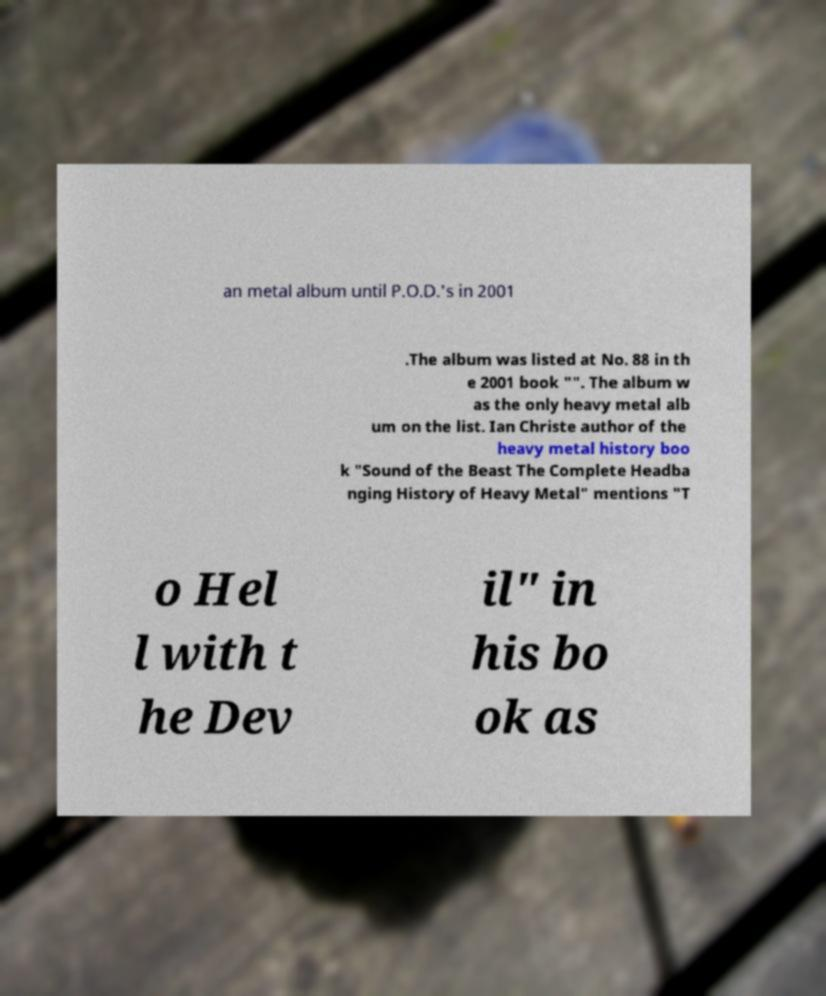For documentation purposes, I need the text within this image transcribed. Could you provide that? an metal album until P.O.D.'s in 2001 .The album was listed at No. 88 in th e 2001 book "". The album w as the only heavy metal alb um on the list. Ian Christe author of the heavy metal history boo k "Sound of the Beast The Complete Headba nging History of Heavy Metal" mentions "T o Hel l with t he Dev il" in his bo ok as 